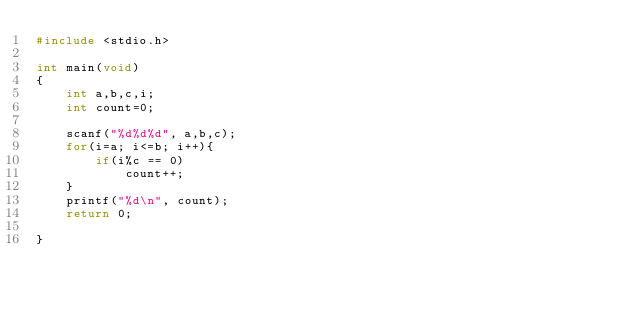Convert code to text. <code><loc_0><loc_0><loc_500><loc_500><_C_>#include <stdio.h>

int main(void)
{
	int a,b,c,i;
	int count=0;

	scanf("%d%d%d", a,b,c);
	for(i=a; i<=b; i++){
		if(i%c == 0)
			count++;
	}
	printf("%d\n", count);
	return 0;

}</code> 